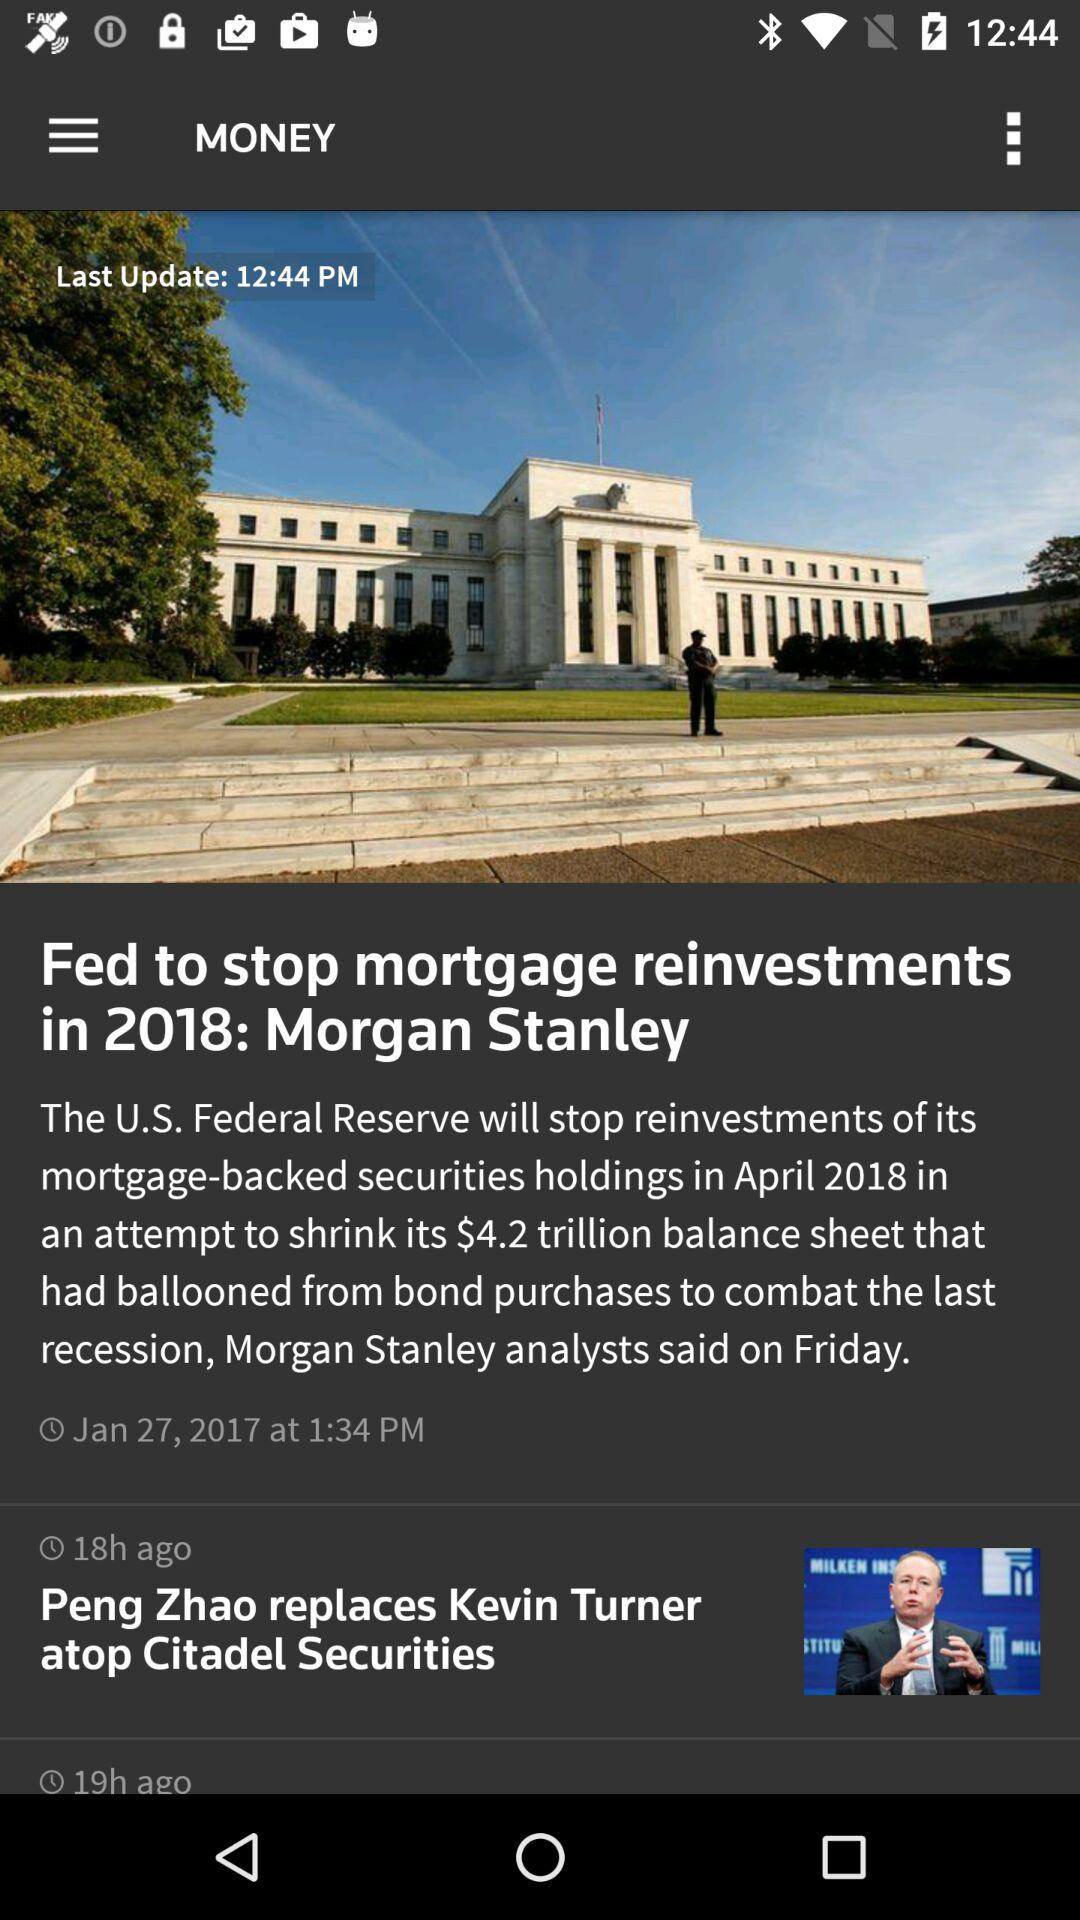What is the last update time shown here? The last update time shown is 12:44 PM. 